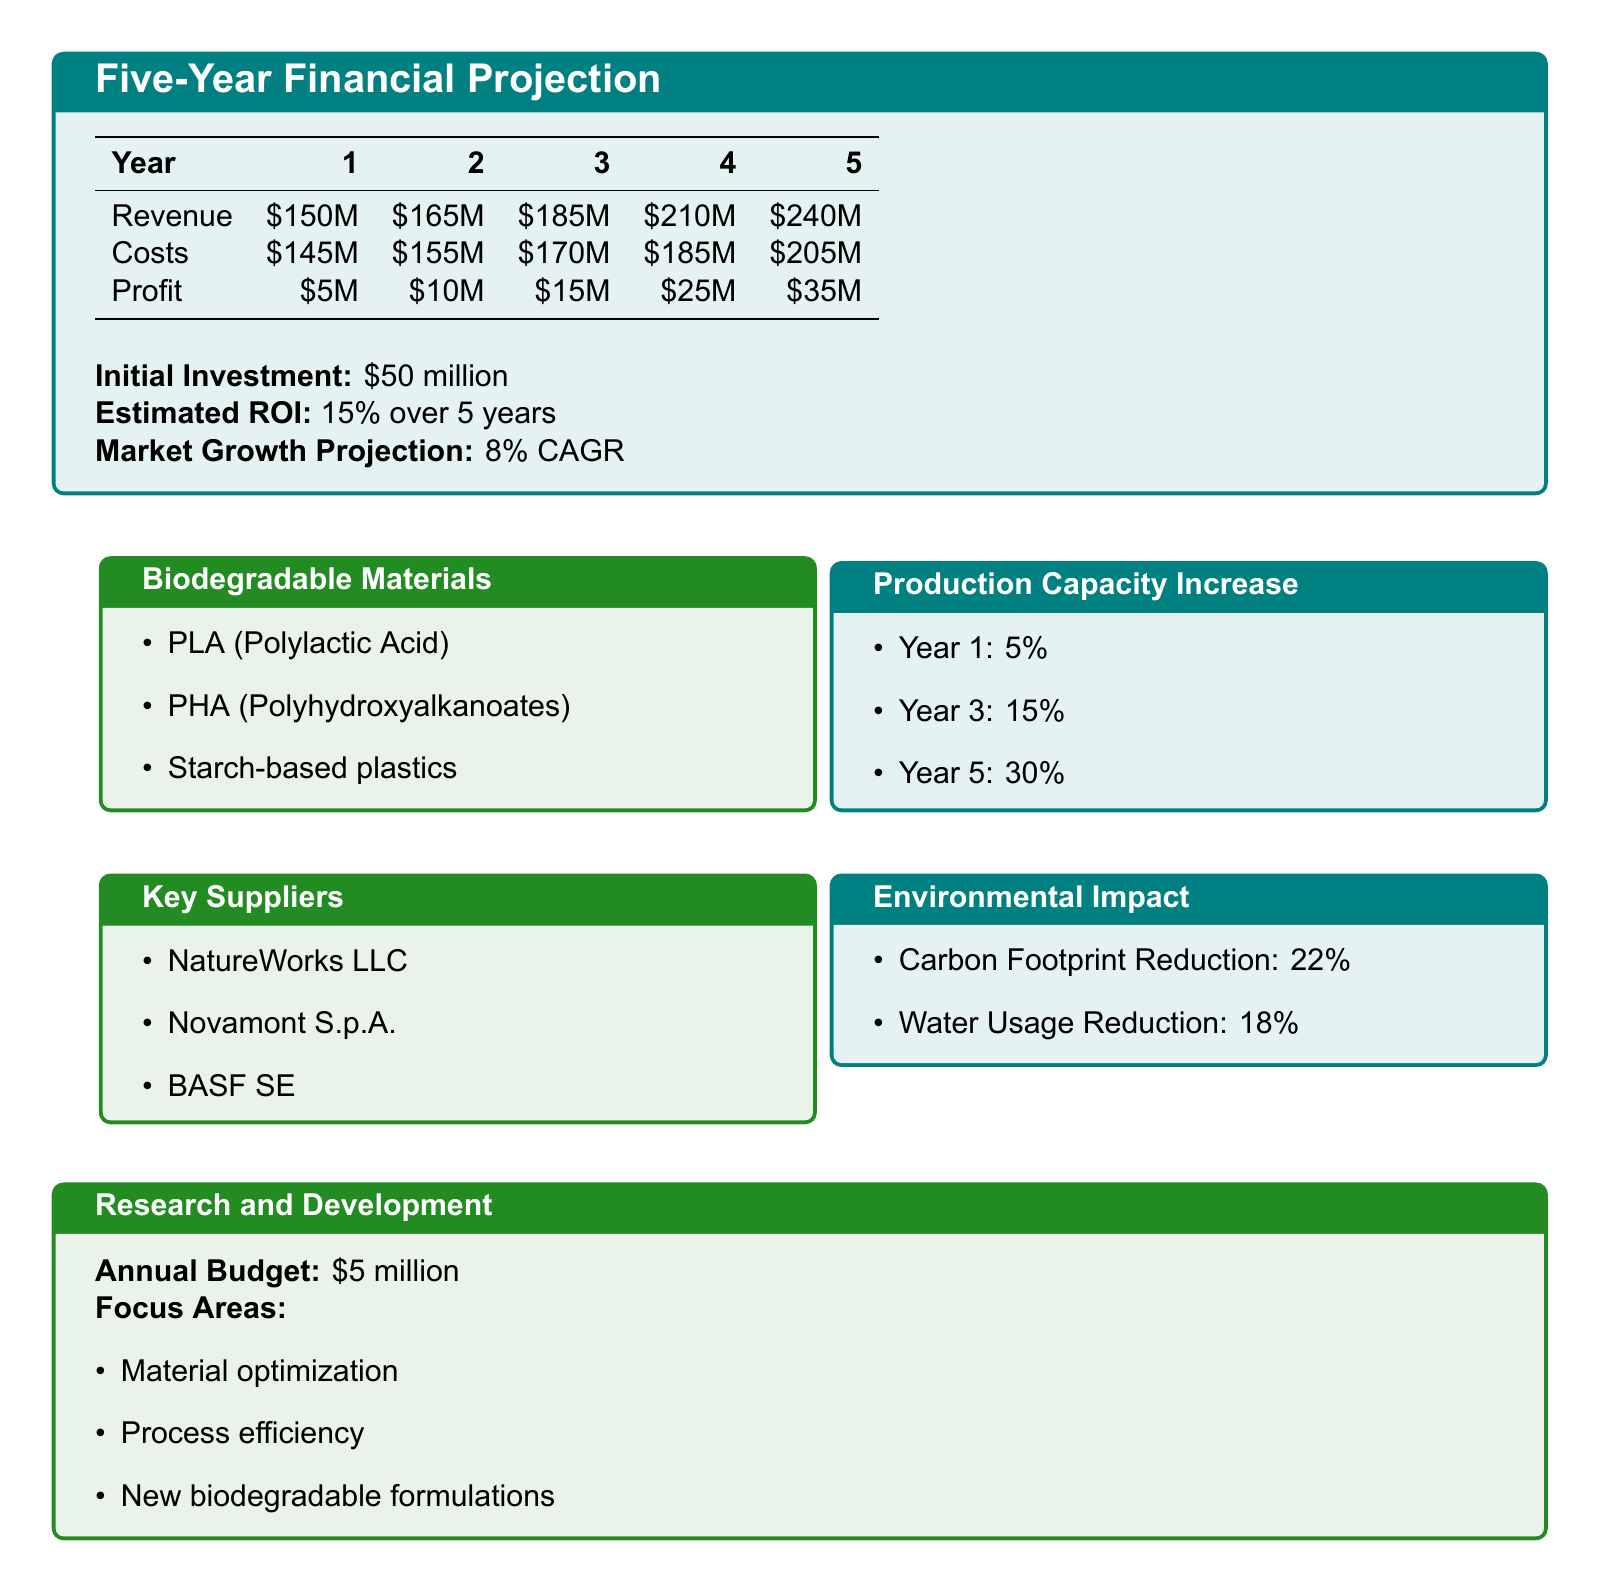What is the total revenue in Year 5? The total revenue in Year 5 is specified in the table, which shows $240 million.
Answer: $240M What is the initial investment amount? The document clearly states the amount for initial investment, which is $50 million.
Answer: $50 million What is the estimated ROI over 5 years? The estimated ROI over 5 years is mentioned directly, which is 15 percent.
Answer: 15% Which biodegradable material is mentioned first in the list? The first biodegradable material listed in the document is PLA (Polylactic Acid).
Answer: PLA (Polylactic Acid) What is the production capacity increase by Year 5? The document specifies that the production capacity increase by Year 5 is 30 percent.
Answer: 30% What is the annual budget for Research and Development? The document states the annual budget for Research and Development is $5 million.
Answer: $5 million How much is the profit in Year 3? The profit in Year 3 is listed in the table, which is $15 million.
Answer: $15M What is the projected market growth rate (CAGR)? The document mentions the market growth projection as 8 percent CAGR.
Answer: 8% CAGR What is the carbon footprint reduction percentage? The carbon footprint reduction is mentioned directly as 22 percent in the environmental impact section.
Answer: 22% 